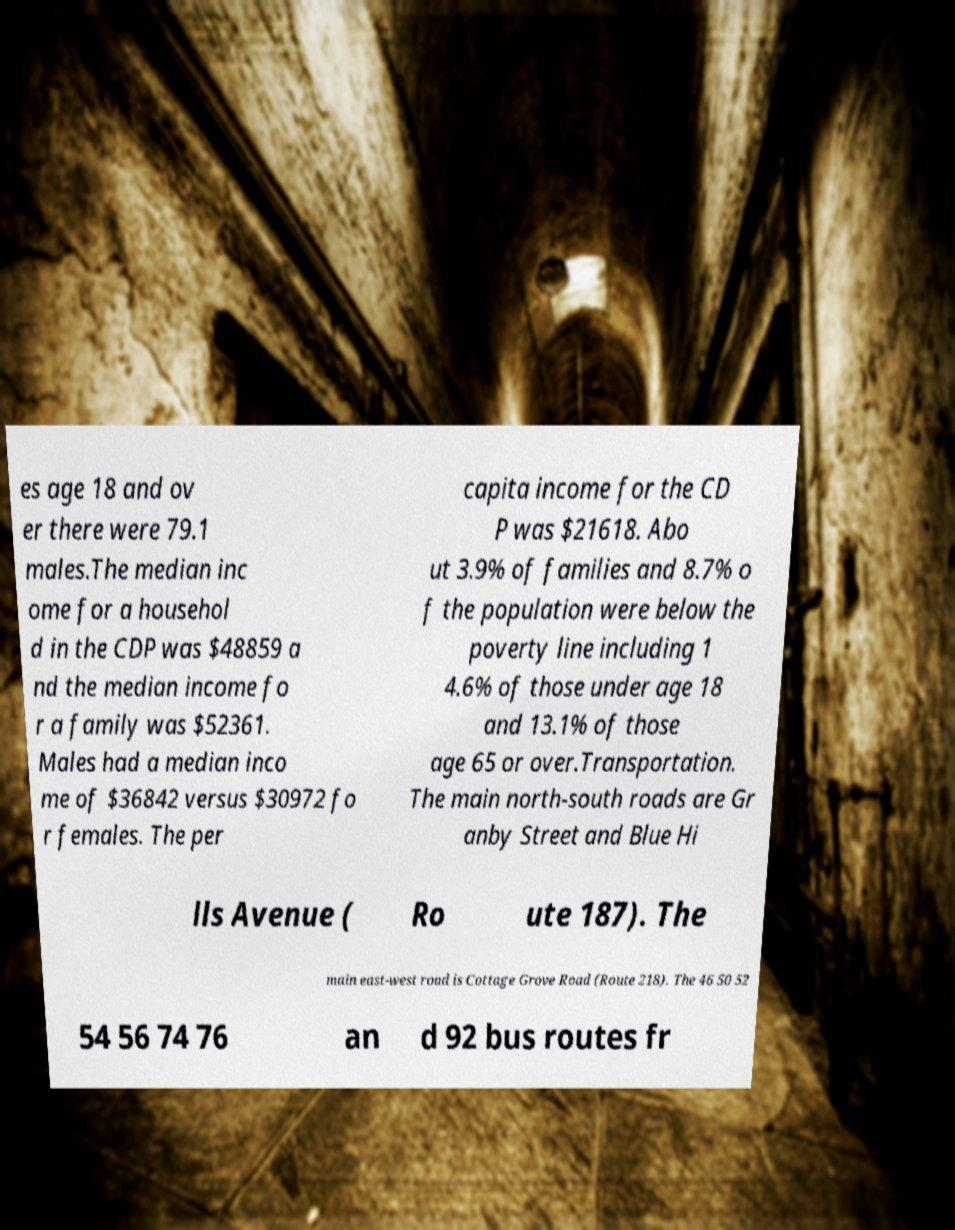Please identify and transcribe the text found in this image. es age 18 and ov er there were 79.1 males.The median inc ome for a househol d in the CDP was $48859 a nd the median income fo r a family was $52361. Males had a median inco me of $36842 versus $30972 fo r females. The per capita income for the CD P was $21618. Abo ut 3.9% of families and 8.7% o f the population were below the poverty line including 1 4.6% of those under age 18 and 13.1% of those age 65 or over.Transportation. The main north-south roads are Gr anby Street and Blue Hi lls Avenue ( Ro ute 187). The main east-west road is Cottage Grove Road (Route 218). The 46 50 52 54 56 74 76 an d 92 bus routes fr 